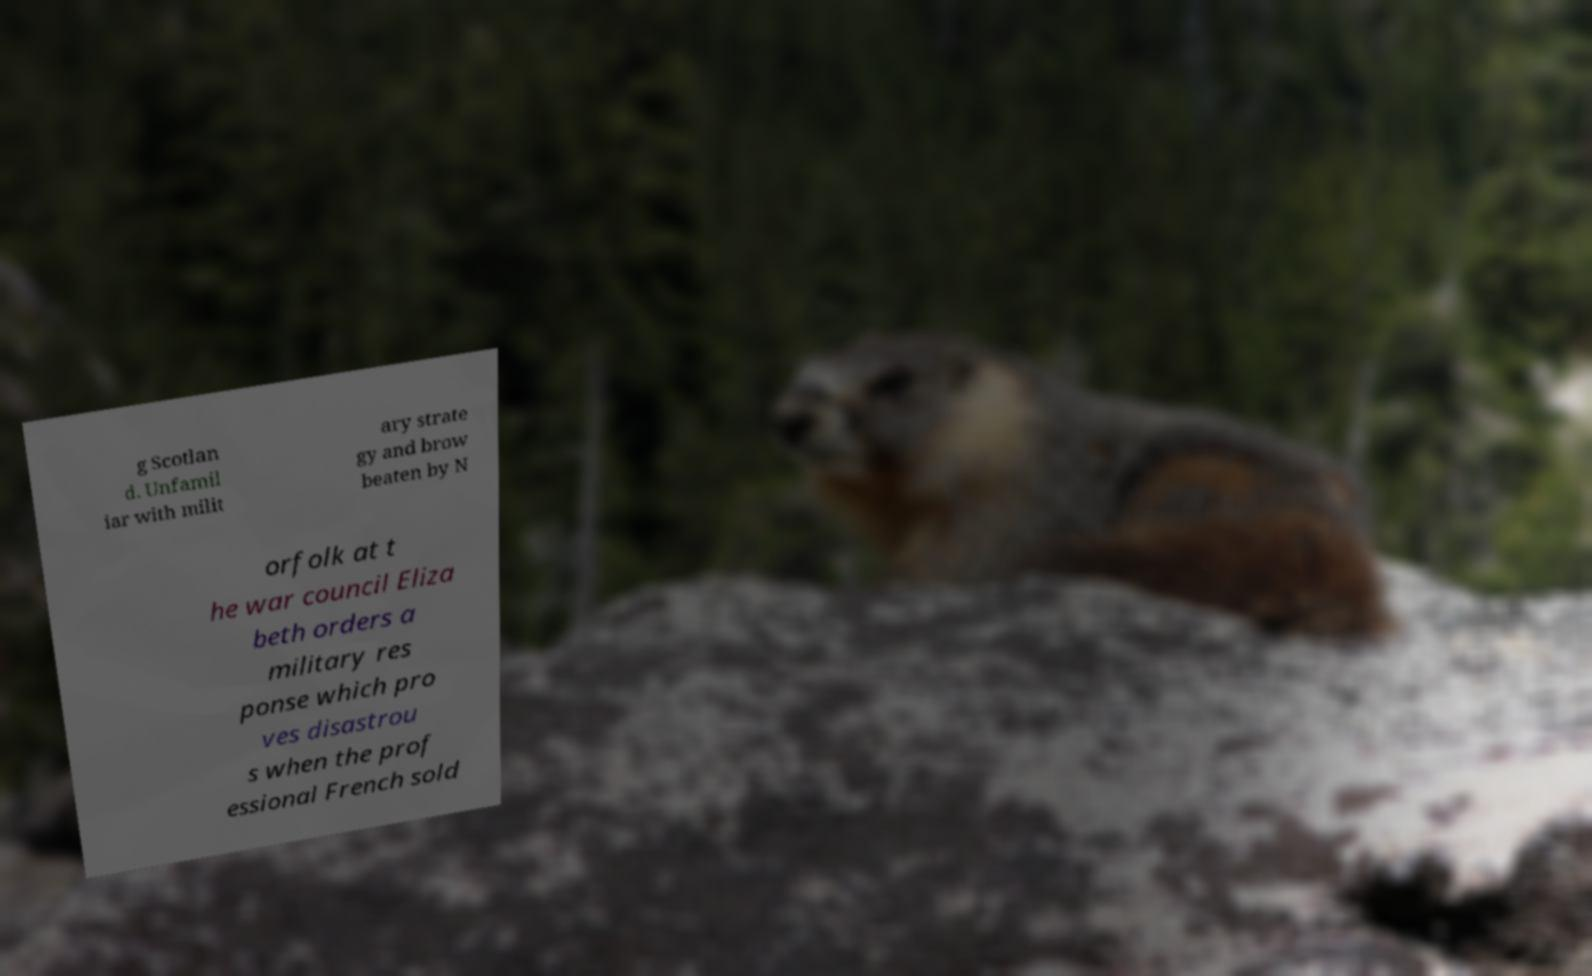I need the written content from this picture converted into text. Can you do that? g Scotlan d. Unfamil iar with milit ary strate gy and brow beaten by N orfolk at t he war council Eliza beth orders a military res ponse which pro ves disastrou s when the prof essional French sold 